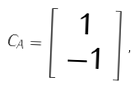<formula> <loc_0><loc_0><loc_500><loc_500>C _ { A } = \left [ \begin{array} { c } 1 \\ - 1 \end{array} \right ] ,</formula> 